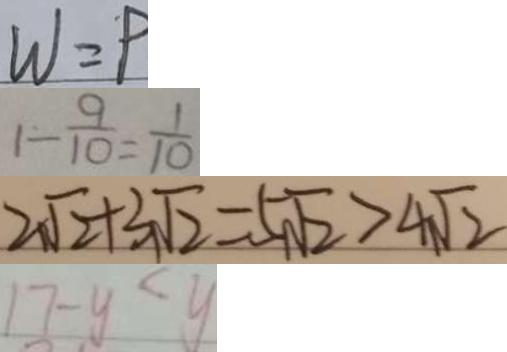<formula> <loc_0><loc_0><loc_500><loc_500>W = P 
 1 - \frac { 9 } { 1 0 } = \frac { 1 } { 1 0 } 
 2 \sqrt { 2 } + 3 \sqrt { 2 } = 5 \sqrt { 2 } > 4 \sqrt { 2 } 
 1 7 - y < y</formula> 